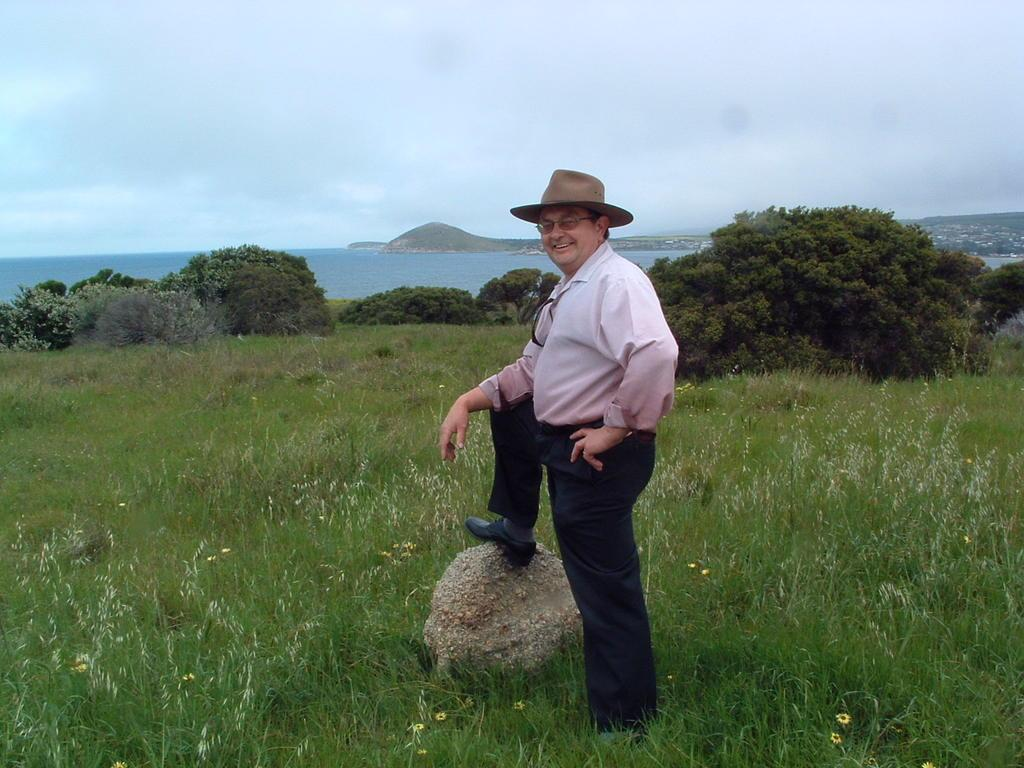What is the person in the image doing? The person is standing on the grass in the image. What type of environment can be seen in the background? There is a beach visible in the image. What type of vegetation is present in the image? There are plants present in the image. What type of camera is the person using to take pictures of the fan in the image? There is no camera or fan present in the image; the person is simply standing on the grass with a beach visible in the background. 